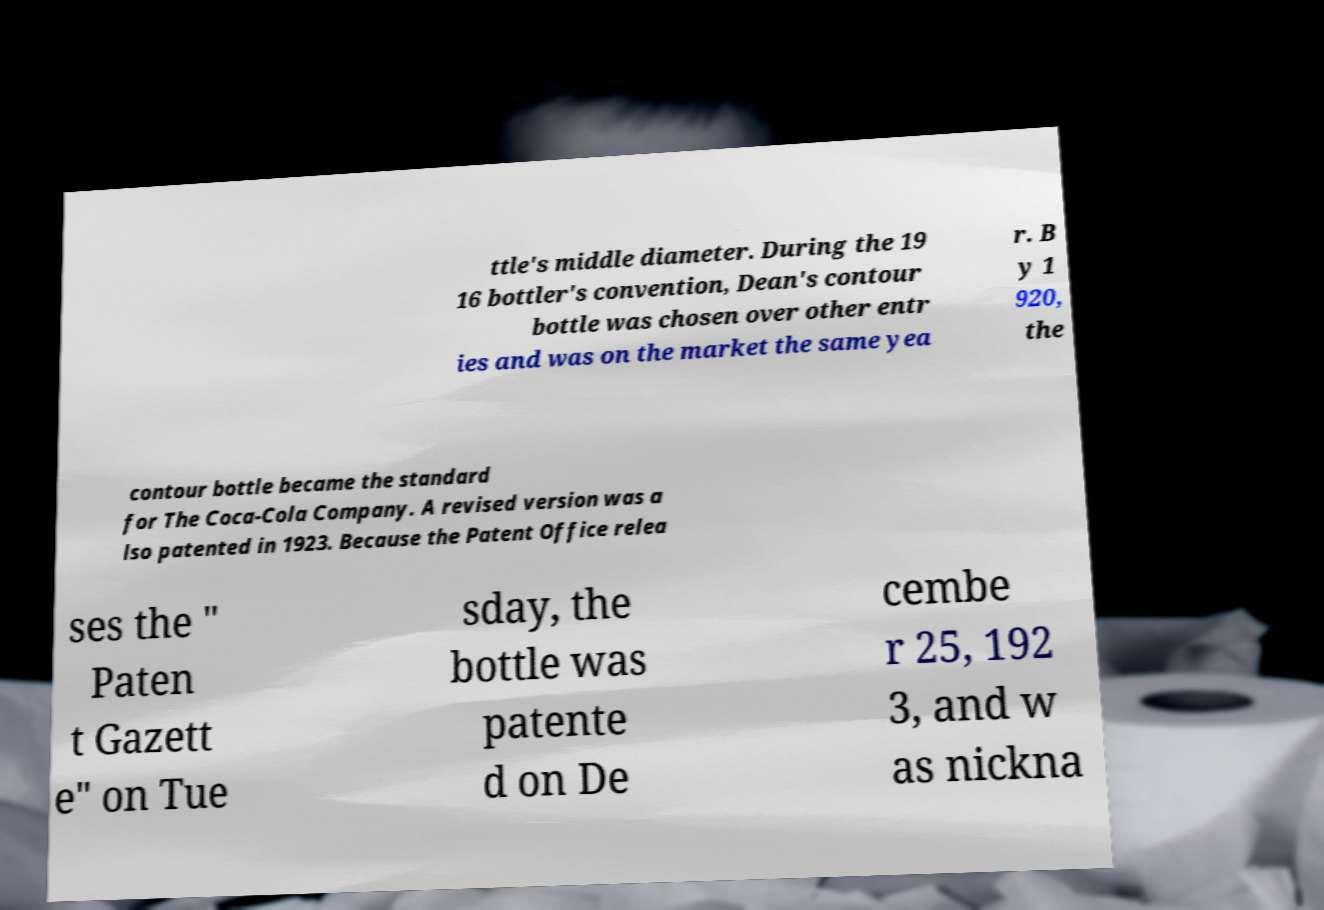What messages or text are displayed in this image? I need them in a readable, typed format. ttle's middle diameter. During the 19 16 bottler's convention, Dean's contour bottle was chosen over other entr ies and was on the market the same yea r. B y 1 920, the contour bottle became the standard for The Coca-Cola Company. A revised version was a lso patented in 1923. Because the Patent Office relea ses the " Paten t Gazett e" on Tue sday, the bottle was patente d on De cembe r 25, 192 3, and w as nickna 